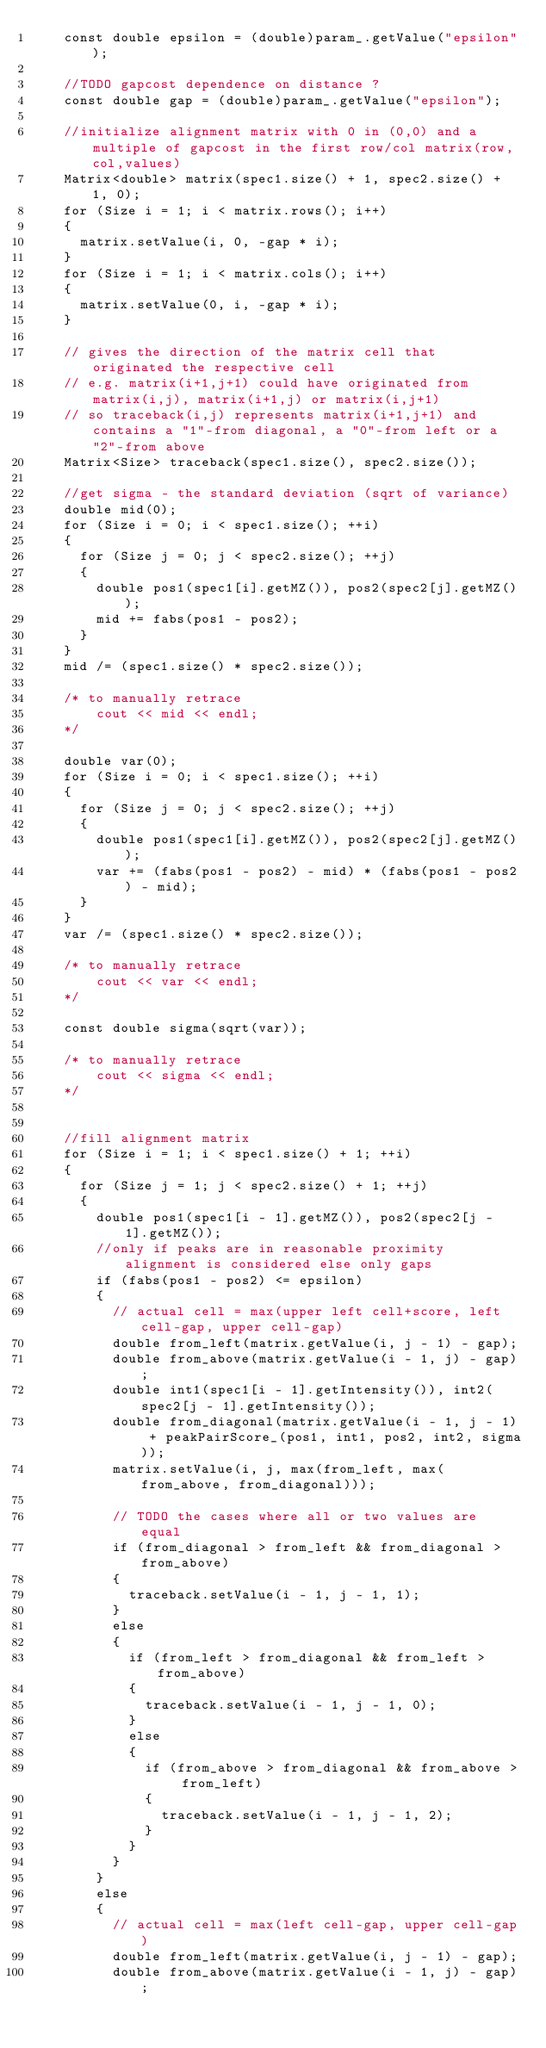Convert code to text. <code><loc_0><loc_0><loc_500><loc_500><_C++_>    const double epsilon = (double)param_.getValue("epsilon");

    //TODO gapcost dependence on distance ?
    const double gap = (double)param_.getValue("epsilon");

    //initialize alignment matrix with 0 in (0,0) and a multiple of gapcost in the first row/col matrix(row,col,values)
    Matrix<double> matrix(spec1.size() + 1, spec2.size() + 1, 0);
    for (Size i = 1; i < matrix.rows(); i++)
    {
      matrix.setValue(i, 0, -gap * i);
    }
    for (Size i = 1; i < matrix.cols(); i++)
    {
      matrix.setValue(0, i, -gap * i);
    }

    // gives the direction of the matrix cell that originated the respective cell
    // e.g. matrix(i+1,j+1) could have originated from matrix(i,j), matrix(i+1,j) or matrix(i,j+1)
    // so traceback(i,j) represents matrix(i+1,j+1) and contains a "1"-from diagonal, a "0"-from left or a "2"-from above
    Matrix<Size> traceback(spec1.size(), spec2.size());

    //get sigma - the standard deviation (sqrt of variance)
    double mid(0);
    for (Size i = 0; i < spec1.size(); ++i)
    {
      for (Size j = 0; j < spec2.size(); ++j)
      {
        double pos1(spec1[i].getMZ()), pos2(spec2[j].getMZ());
        mid += fabs(pos1 - pos2);
      }
    }
    mid /= (spec1.size() * spec2.size());

    /* to manually retrace
        cout << mid << endl;
    */

    double var(0);
    for (Size i = 0; i < spec1.size(); ++i)
    {
      for (Size j = 0; j < spec2.size(); ++j)
      {
        double pos1(spec1[i].getMZ()), pos2(spec2[j].getMZ());
        var += (fabs(pos1 - pos2) - mid) * (fabs(pos1 - pos2) - mid);
      }
    }
    var /= (spec1.size() * spec2.size());

    /* to manually retrace
        cout << var << endl;
    */

    const double sigma(sqrt(var));

    /* to manually retrace
        cout << sigma << endl;
    */


    //fill alignment matrix
    for (Size i = 1; i < spec1.size() + 1; ++i)
    {
      for (Size j = 1; j < spec2.size() + 1; ++j)
      {
        double pos1(spec1[i - 1].getMZ()), pos2(spec2[j - 1].getMZ());
        //only if peaks are in reasonable proximity alignment is considered else only gaps
        if (fabs(pos1 - pos2) <= epsilon)
        {
          // actual cell = max(upper left cell+score, left cell-gap, upper cell-gap)
          double from_left(matrix.getValue(i, j - 1) - gap);
          double from_above(matrix.getValue(i - 1, j) - gap);
          double int1(spec1[i - 1].getIntensity()), int2(spec2[j - 1].getIntensity());
          double from_diagonal(matrix.getValue(i - 1, j - 1) + peakPairScore_(pos1, int1, pos2, int2, sigma));
          matrix.setValue(i, j, max(from_left, max(from_above, from_diagonal)));

          // TODO the cases where all or two values are equal
          if (from_diagonal > from_left && from_diagonal > from_above)
          {
            traceback.setValue(i - 1, j - 1, 1);
          }
          else
          {
            if (from_left > from_diagonal && from_left > from_above)
            {
              traceback.setValue(i - 1, j - 1, 0);
            }
            else
            {
              if (from_above > from_diagonal && from_above > from_left)
              {
                traceback.setValue(i - 1, j - 1, 2);
              }
            }
          }
        }
        else
        {
          // actual cell = max(left cell-gap, upper cell-gap)
          double from_left(matrix.getValue(i, j - 1) - gap);
          double from_above(matrix.getValue(i - 1, j) - gap);</code> 